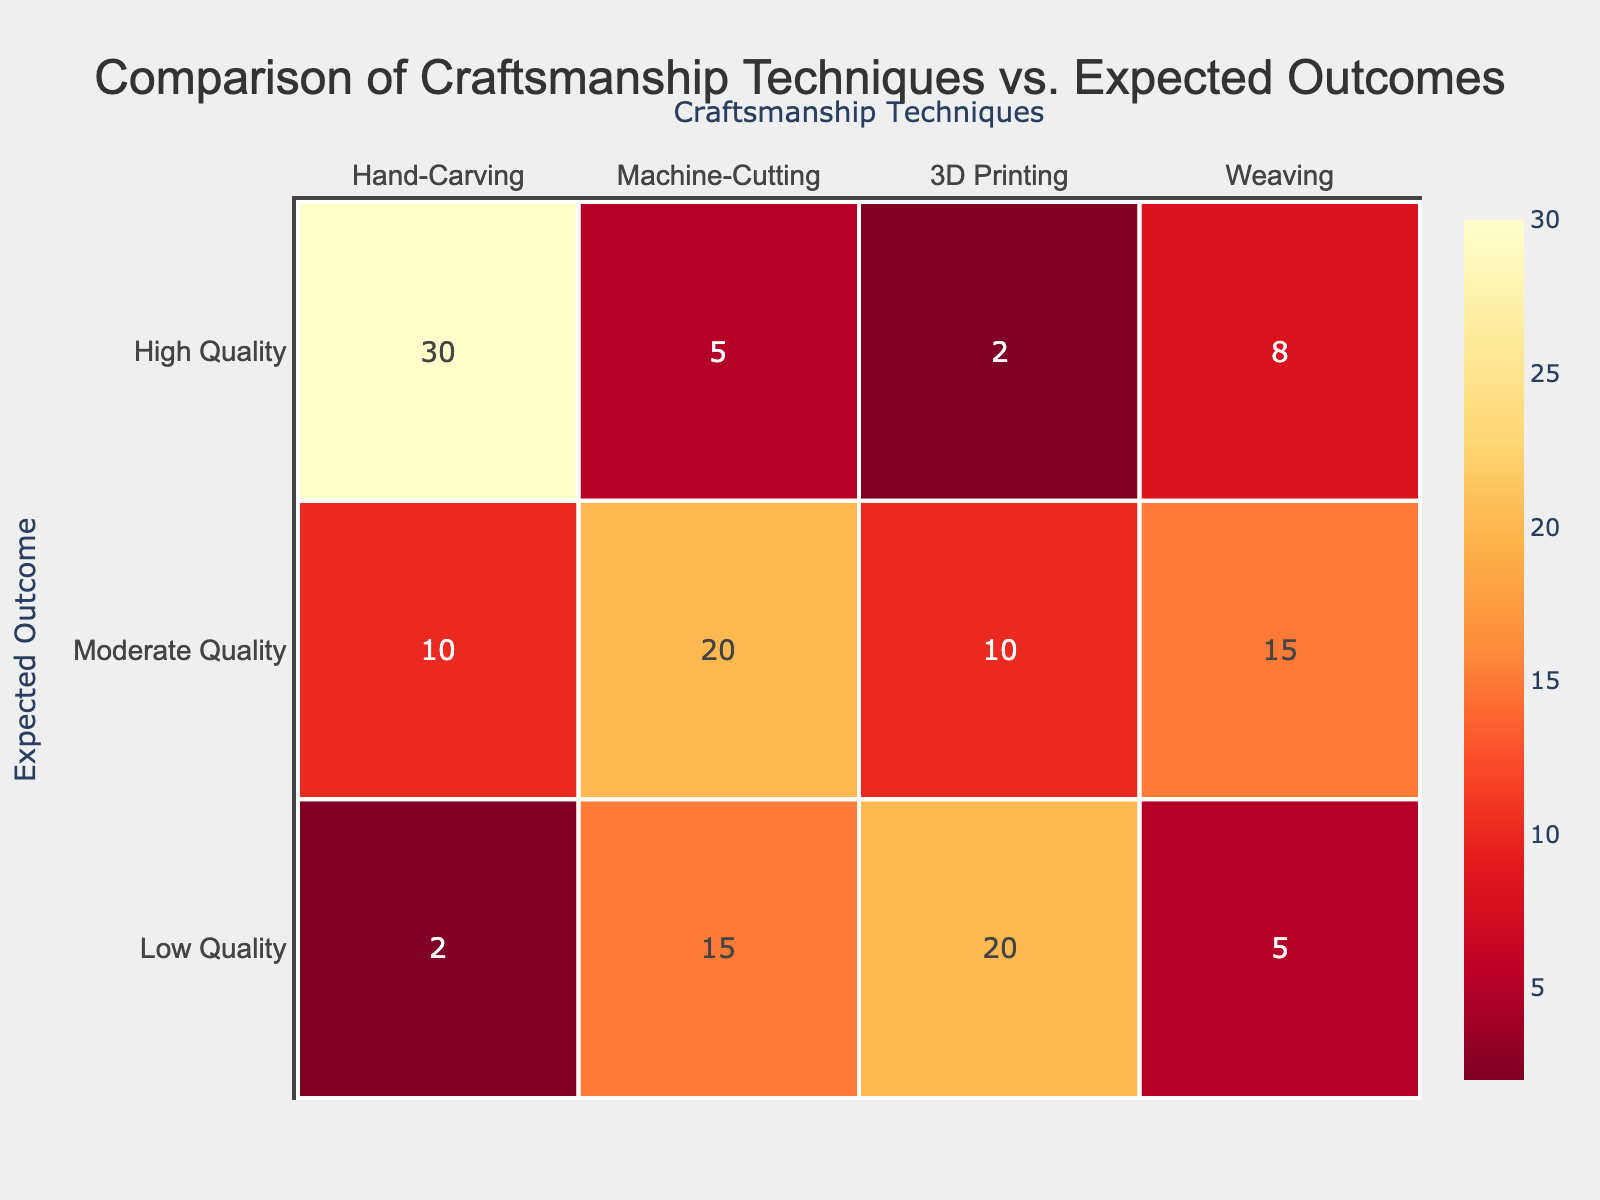What is the highest count of expected outcomes for Hand-Carving? Looking at the Hand-Carving column, the highest count corresponds to the High Quality row, which has a value of 30.
Answer: 30 What is the total number of Low Quality outcomes across all craftsmanship techniques? To find this, sum the values in the Low Quality row: 2 (Hand-Carving) + 15 (Machine-Cutting) + 20 (3D Printing) + 5 (Weaving) = 42.
Answer: 42 Is Machine-Cutting more likely to produce Moderate Quality outcomes compared to Hand-Carving? In the Moderate Quality row, Machine-Cutting has a count of 20, while Hand-Carving has a count of 10. Since 20 is greater than 10, Machine-Cutting is more likely to produce Moderate Quality outcomes.
Answer: Yes What percentage of High Quality outcomes are produced by 3D Printing? There are a total of 30 (High Quality - Hand-Carving) + 5 (High Quality - Machine-Cutting) + 2 (High Quality - 3D Printing) + 8 (High Quality - Weaving) = 45 High Quality outcomes. The count for 3D Printing in the High Quality row is 2. The percentage is (2/45) * 100 ≈ 4.44%.
Answer: Approximately 4.44% How does the sum of Moderate Quality outcomes for Machine-Cutting and Weaving compare to the sum for Hand-Carving and 3D Printing? The sum for Machine-Cutting (20) and Weaving (15) is 20 + 15 = 35. The sum for Hand-Carving (10) and 3D Printing (10) is 10 + 10 = 20. Since 35 is greater than 20, Machine-Cutting and Weaving combined produce higher Moderate Quality outcomes.
Answer: Machine-Cutting and Weaving have a higher sum 